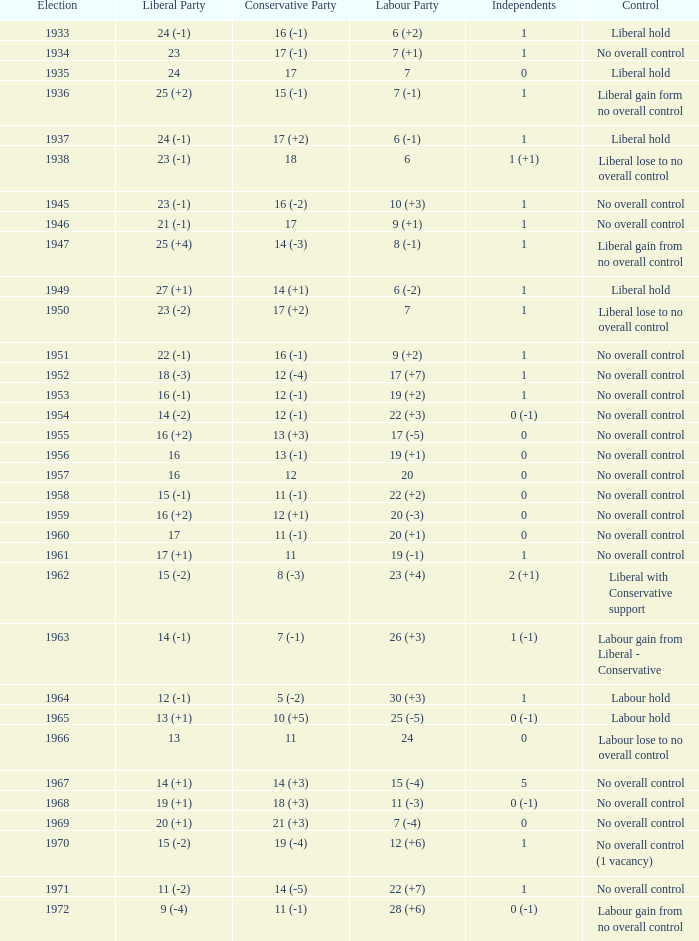What is the number of Independents elected in the year Labour won 26 (+3) seats? 1 (-1). 